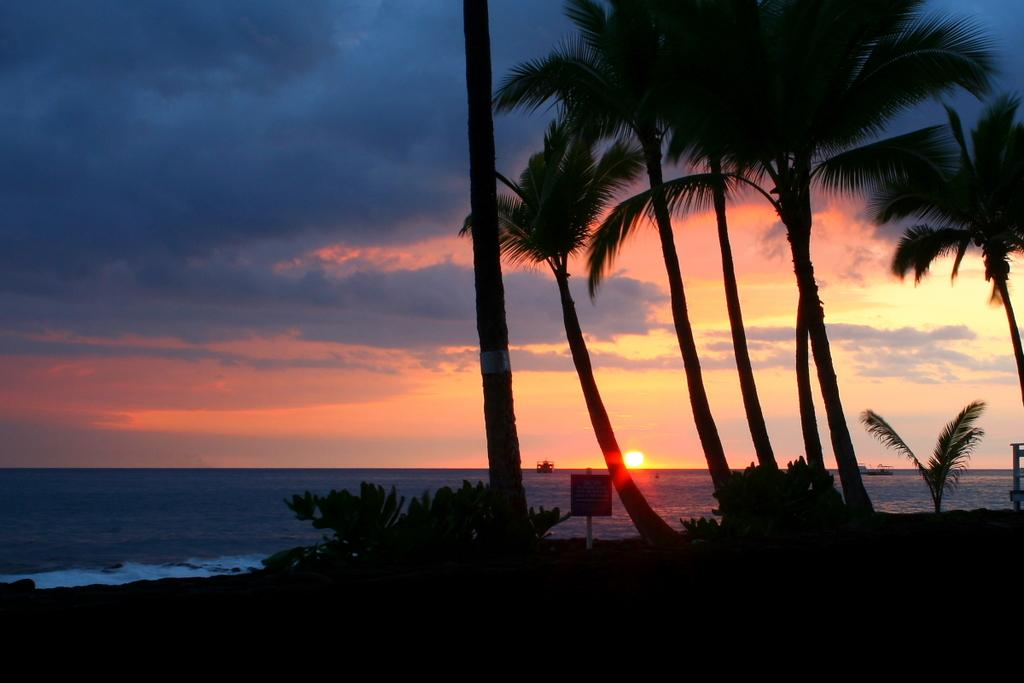What is one of the main elements in the image? There is water in the image. What other natural elements can be seen in the image? There are trees in the image. What object is present in the image? There is a board in the image. What can be seen in the background of the image? The sky is visible in the background of the image. What atmospheric feature is present in the sky? Clouds are present in the sky. What type of jar can be seen in the image? There is no jar present in the image. What is the texture of the wealth in the image? There is no wealth present in the image, so it is not possible to determine its texture. 